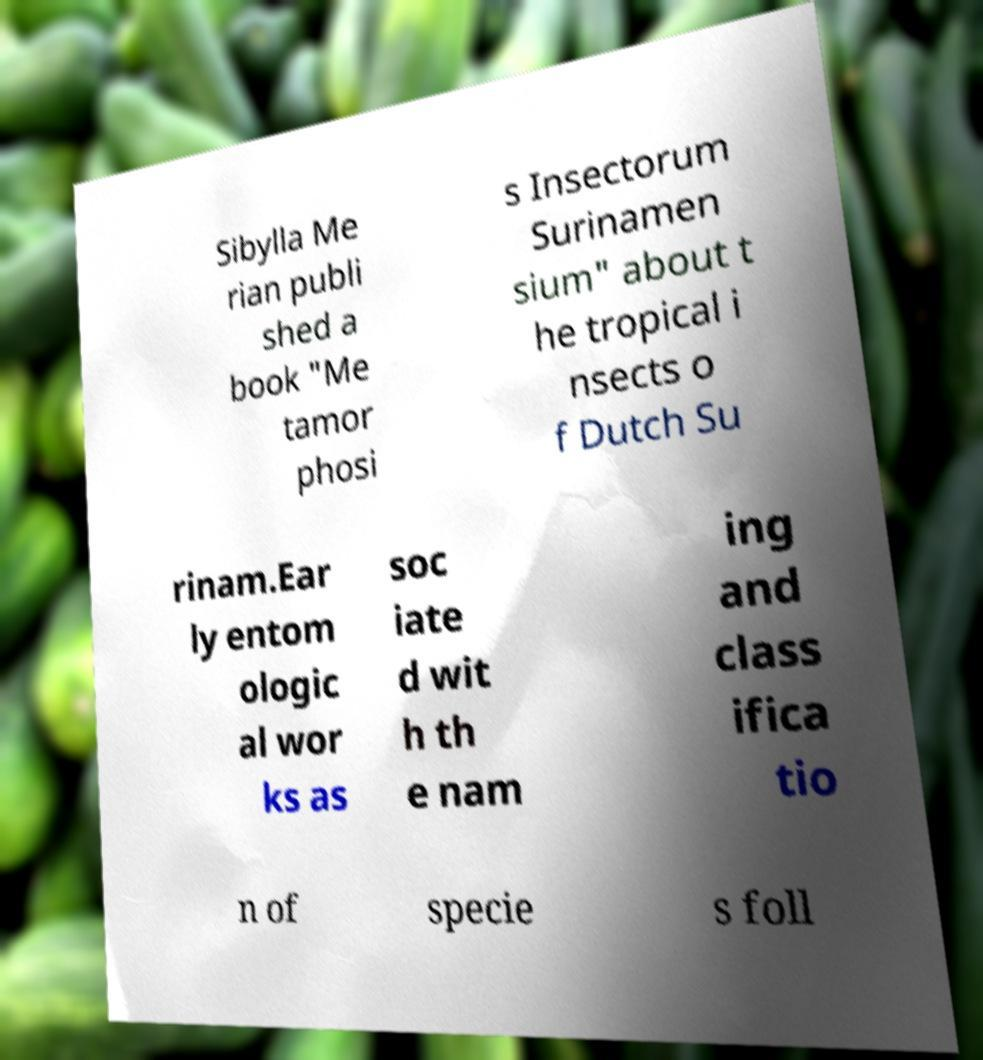Can you accurately transcribe the text from the provided image for me? Sibylla Me rian publi shed a book "Me tamor phosi s Insectorum Surinamen sium" about t he tropical i nsects o f Dutch Su rinam.Ear ly entom ologic al wor ks as soc iate d wit h th e nam ing and class ifica tio n of specie s foll 